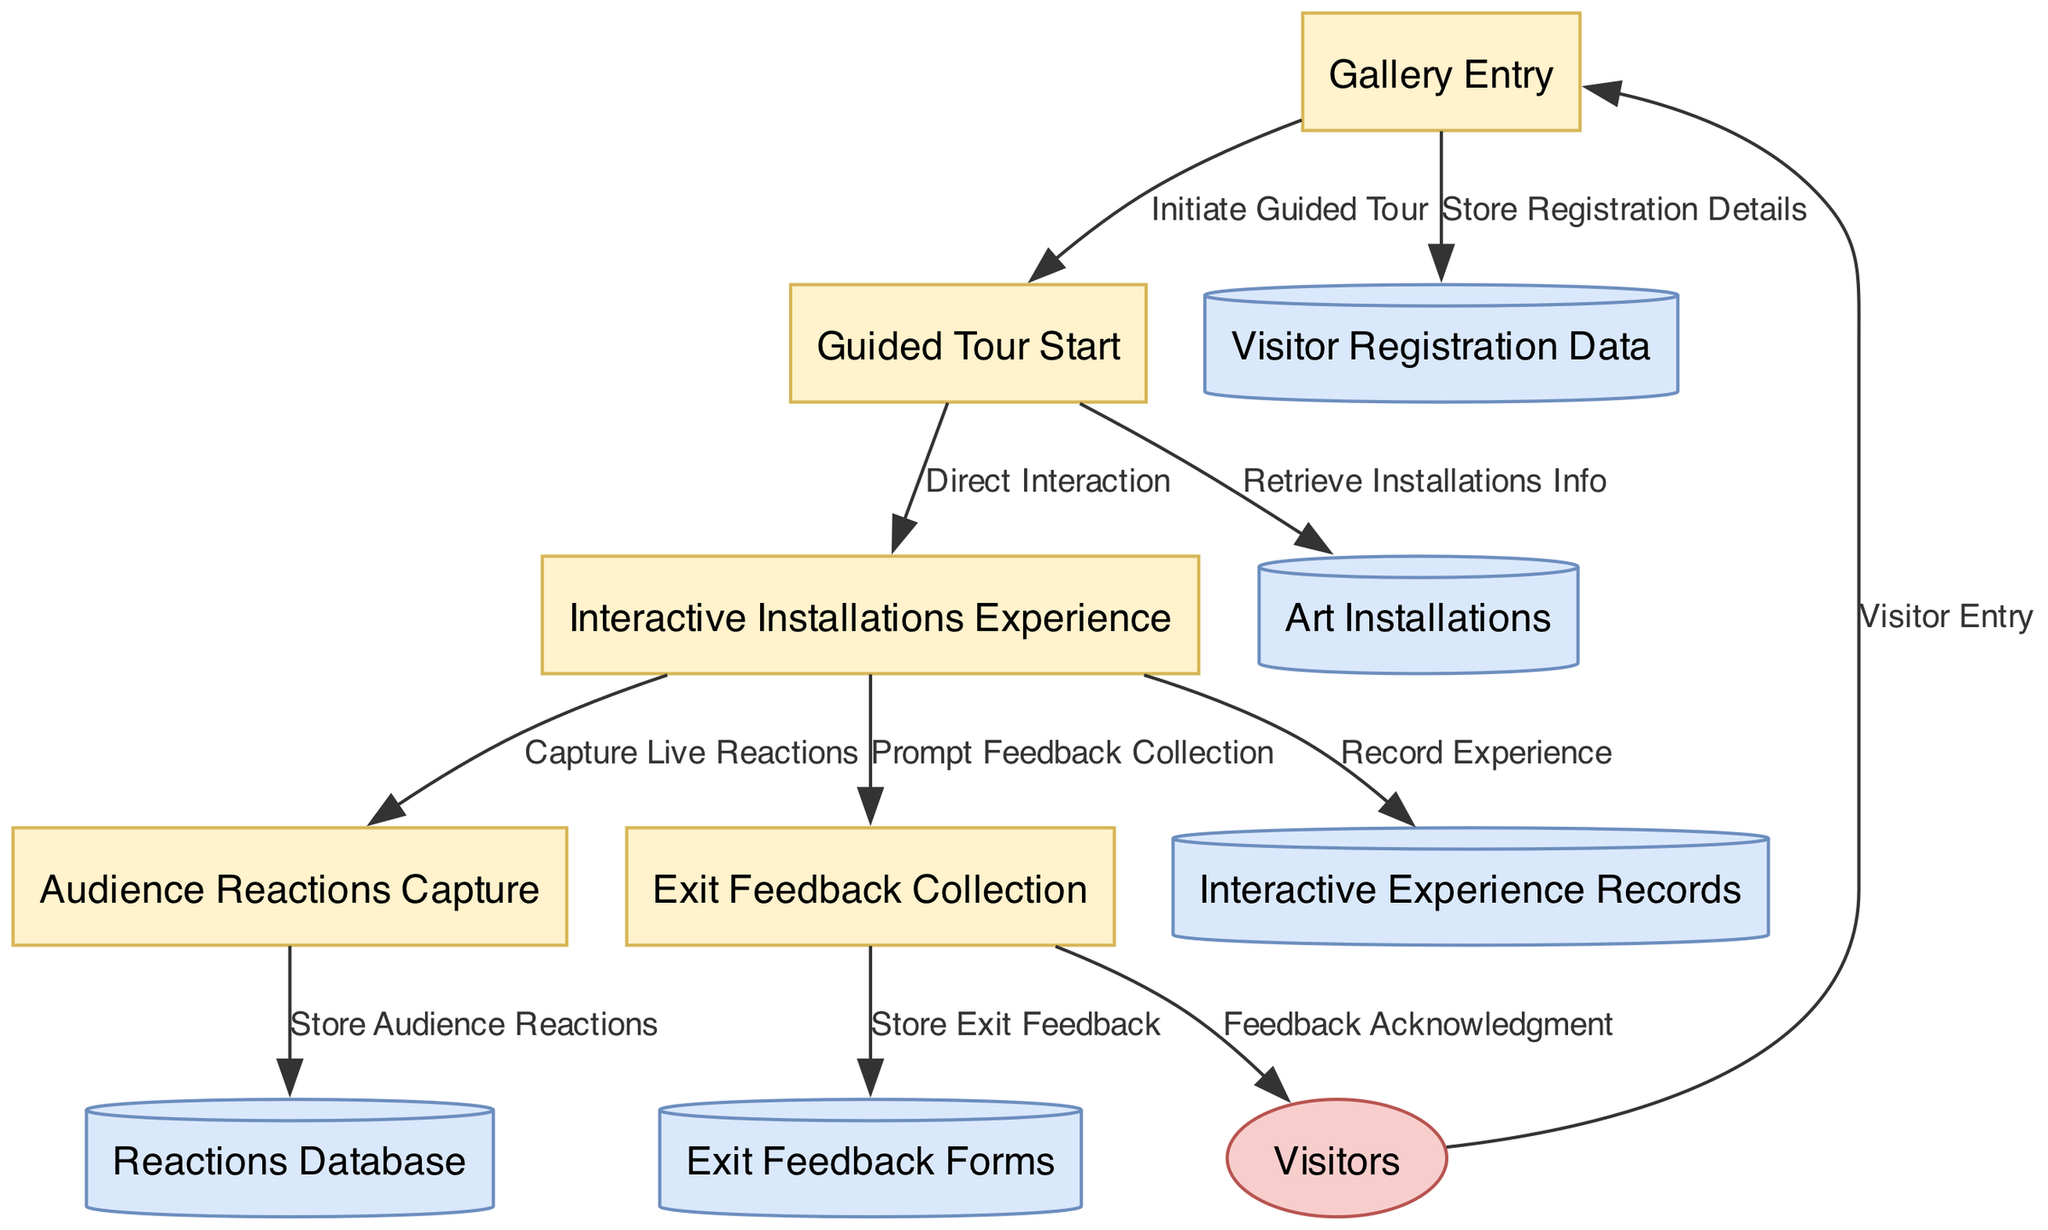What's the first process in the diagram? The first process listed in the diagram is "Gallery Entry." This can be directly identified from the "processes" section where it clearly states that the process with ID "1" is named "Gallery Entry."
Answer: Gallery Entry How many data stores are present in the diagram? There are five data stores in the diagram. By counting the entries in the "data_stores" section, we see five distinct data stores listed: Visitor Registration Data, Art Installations, Interactive Experience Records, Reactions Database, and Exit Feedback Forms.
Answer: Five Which process captures audience reactions? The process that captures audience reactions is "Audience Reactions Capture," which is represented by process ID "4." This can be confirmed by locating the specific naming within the processes.
Answer: Audience Reactions Capture What data flows from "Interactive Installations Experience" to "Exit Feedback Collection"? The data that flows from "Interactive Installations Experience" to "Exit Feedback Collection" is "Prompt Feedback Collection." This indicates a direction of interaction where the feedback process is prompted based on the prior interactive experience.
Answer: Prompt Feedback Collection Which external entity is involved at the start of the diagram? The external entity involved at the start of the diagram is "Visitors." This can be found in the "external_entities" section, where the only listed entity is visitors, representing the audience interacting with the gallery.
Answer: Visitors What is the purpose of the data flow from "Audience Reactions Capture" to "Reactions Database"? The purpose of this data flow is to "Store Audience Reactions." This flow indicates that the audience's reactions captured during the experience are then stored in a dedicated database for future reference or analysis.
Answer: Store Audience Reactions What is the last data flow that connects to external entities? The last data flow that connects to external entities is "Feedback Acknowledgment." This flow goes from "Exit Feedback Collection" to "Visitors," indicating that once the feedback forms are collected, the visitors receive an acknowledgment of their feedback.
Answer: Feedback Acknowledgment Which process initiates the guided tour? The process that initiates the guided tour is "Guided Tour Start." This can be seen as a clear action initiated after the "Gallery Entry," indicating the second step in the process flow.
Answer: Guided Tour Start What is stored in the "Visitor Registration Data"? The "Visitor Registration Data" stores "Registration Details." This information is specifically collected during the "Gallery Entry" process, which aims to gather information about the visitors for processing.
Answer: Registration Details 